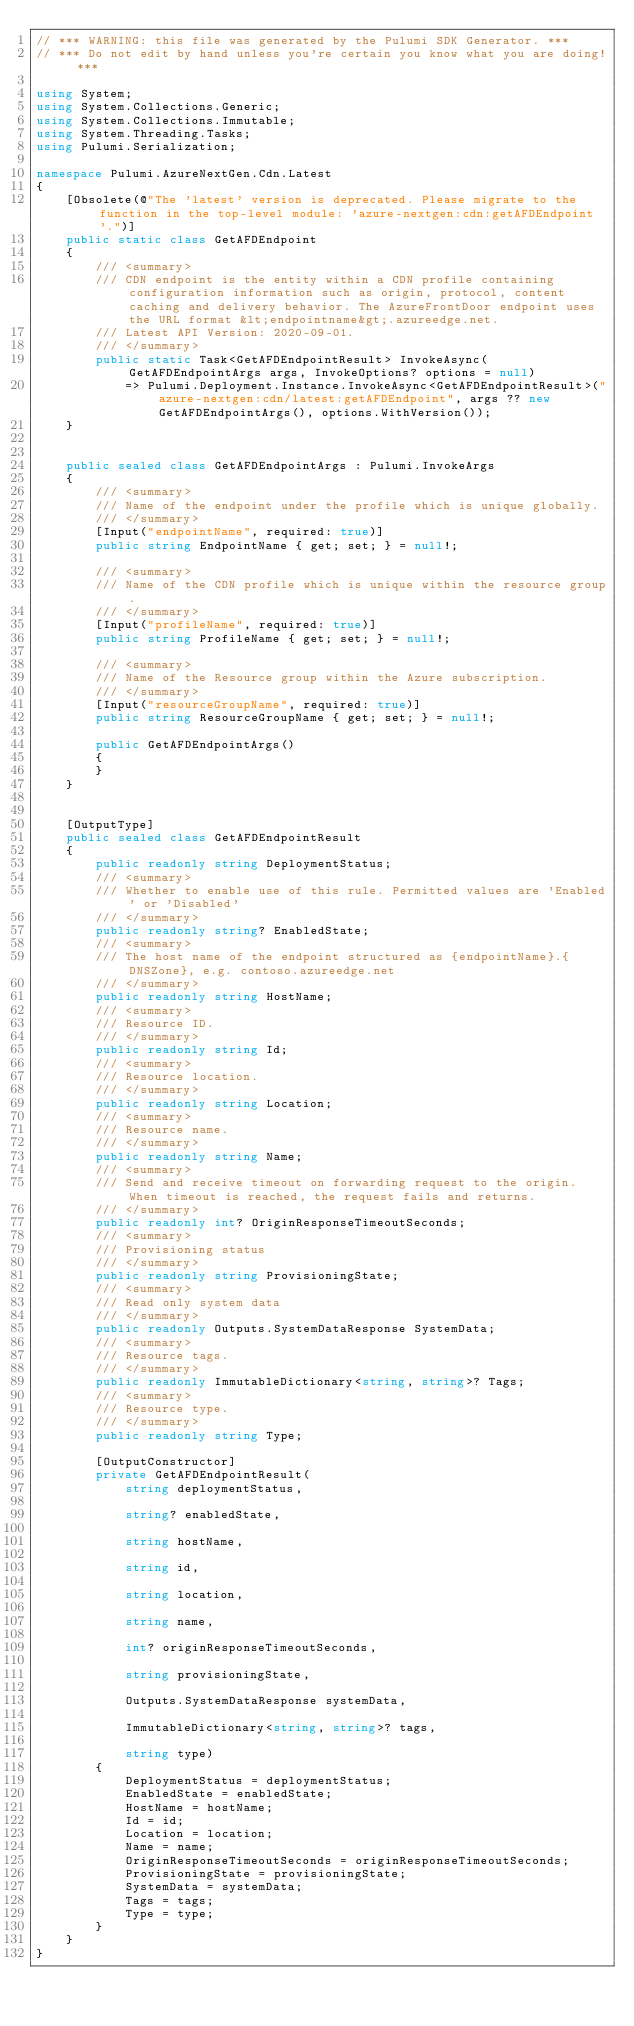<code> <loc_0><loc_0><loc_500><loc_500><_C#_>// *** WARNING: this file was generated by the Pulumi SDK Generator. ***
// *** Do not edit by hand unless you're certain you know what you are doing! ***

using System;
using System.Collections.Generic;
using System.Collections.Immutable;
using System.Threading.Tasks;
using Pulumi.Serialization;

namespace Pulumi.AzureNextGen.Cdn.Latest
{
    [Obsolete(@"The 'latest' version is deprecated. Please migrate to the function in the top-level module: 'azure-nextgen:cdn:getAFDEndpoint'.")]
    public static class GetAFDEndpoint
    {
        /// <summary>
        /// CDN endpoint is the entity within a CDN profile containing configuration information such as origin, protocol, content caching and delivery behavior. The AzureFrontDoor endpoint uses the URL format &lt;endpointname&gt;.azureedge.net.
        /// Latest API Version: 2020-09-01.
        /// </summary>
        public static Task<GetAFDEndpointResult> InvokeAsync(GetAFDEndpointArgs args, InvokeOptions? options = null)
            => Pulumi.Deployment.Instance.InvokeAsync<GetAFDEndpointResult>("azure-nextgen:cdn/latest:getAFDEndpoint", args ?? new GetAFDEndpointArgs(), options.WithVersion());
    }


    public sealed class GetAFDEndpointArgs : Pulumi.InvokeArgs
    {
        /// <summary>
        /// Name of the endpoint under the profile which is unique globally.
        /// </summary>
        [Input("endpointName", required: true)]
        public string EndpointName { get; set; } = null!;

        /// <summary>
        /// Name of the CDN profile which is unique within the resource group.
        /// </summary>
        [Input("profileName", required: true)]
        public string ProfileName { get; set; } = null!;

        /// <summary>
        /// Name of the Resource group within the Azure subscription.
        /// </summary>
        [Input("resourceGroupName", required: true)]
        public string ResourceGroupName { get; set; } = null!;

        public GetAFDEndpointArgs()
        {
        }
    }


    [OutputType]
    public sealed class GetAFDEndpointResult
    {
        public readonly string DeploymentStatus;
        /// <summary>
        /// Whether to enable use of this rule. Permitted values are 'Enabled' or 'Disabled'
        /// </summary>
        public readonly string? EnabledState;
        /// <summary>
        /// The host name of the endpoint structured as {endpointName}.{DNSZone}, e.g. contoso.azureedge.net
        /// </summary>
        public readonly string HostName;
        /// <summary>
        /// Resource ID.
        /// </summary>
        public readonly string Id;
        /// <summary>
        /// Resource location.
        /// </summary>
        public readonly string Location;
        /// <summary>
        /// Resource name.
        /// </summary>
        public readonly string Name;
        /// <summary>
        /// Send and receive timeout on forwarding request to the origin. When timeout is reached, the request fails and returns.
        /// </summary>
        public readonly int? OriginResponseTimeoutSeconds;
        /// <summary>
        /// Provisioning status
        /// </summary>
        public readonly string ProvisioningState;
        /// <summary>
        /// Read only system data
        /// </summary>
        public readonly Outputs.SystemDataResponse SystemData;
        /// <summary>
        /// Resource tags.
        /// </summary>
        public readonly ImmutableDictionary<string, string>? Tags;
        /// <summary>
        /// Resource type.
        /// </summary>
        public readonly string Type;

        [OutputConstructor]
        private GetAFDEndpointResult(
            string deploymentStatus,

            string? enabledState,

            string hostName,

            string id,

            string location,

            string name,

            int? originResponseTimeoutSeconds,

            string provisioningState,

            Outputs.SystemDataResponse systemData,

            ImmutableDictionary<string, string>? tags,

            string type)
        {
            DeploymentStatus = deploymentStatus;
            EnabledState = enabledState;
            HostName = hostName;
            Id = id;
            Location = location;
            Name = name;
            OriginResponseTimeoutSeconds = originResponseTimeoutSeconds;
            ProvisioningState = provisioningState;
            SystemData = systemData;
            Tags = tags;
            Type = type;
        }
    }
}
</code> 